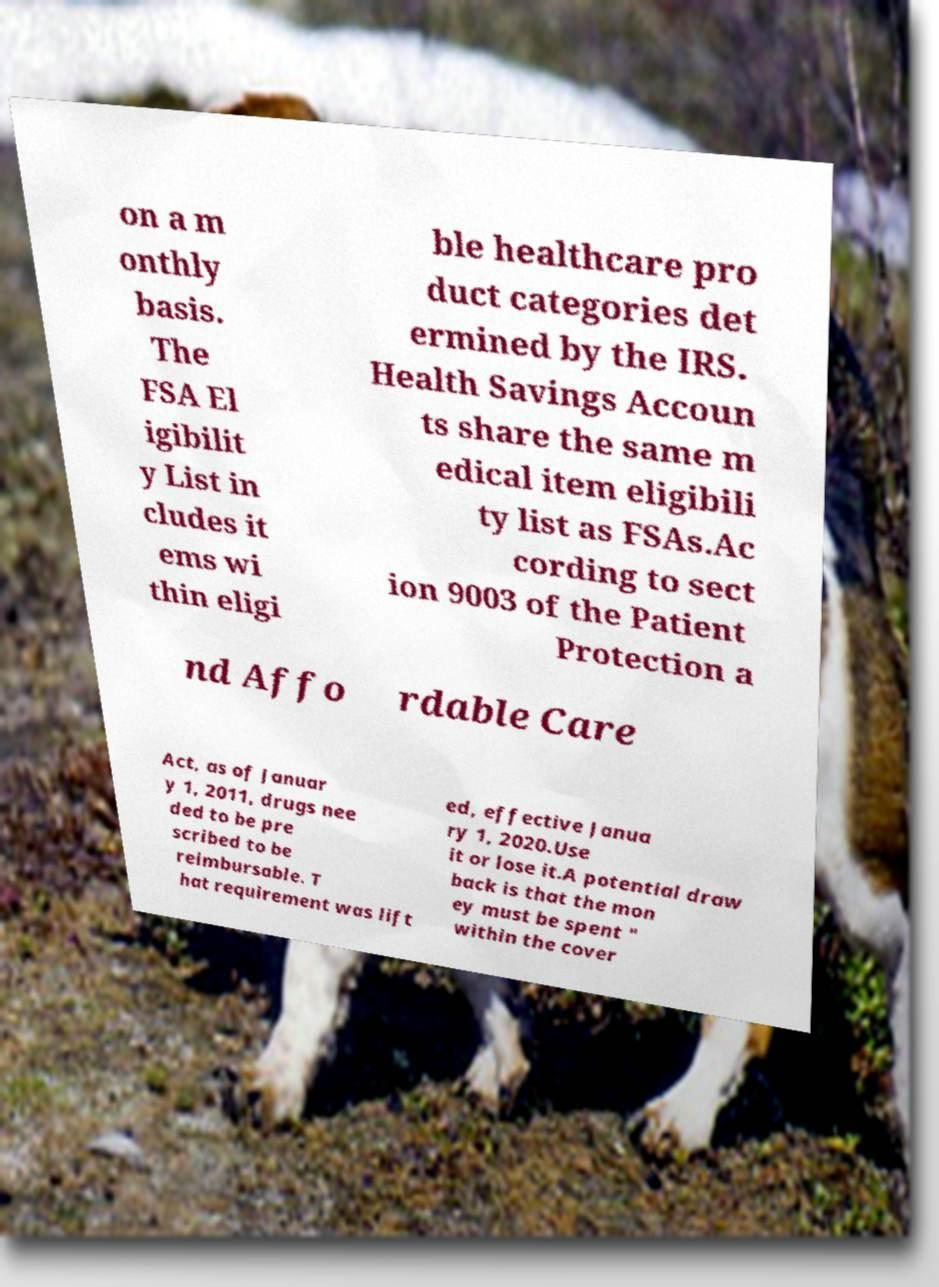There's text embedded in this image that I need extracted. Can you transcribe it verbatim? on a m onthly basis. The FSA El igibilit y List in cludes it ems wi thin eligi ble healthcare pro duct categories det ermined by the IRS. Health Savings Accoun ts share the same m edical item eligibili ty list as FSAs.Ac cording to sect ion 9003 of the Patient Protection a nd Affo rdable Care Act, as of Januar y 1, 2011, drugs nee ded to be pre scribed to be reimbursable. T hat requirement was lift ed, effective Janua ry 1, 2020.Use it or lose it.A potential draw back is that the mon ey must be spent " within the cover 